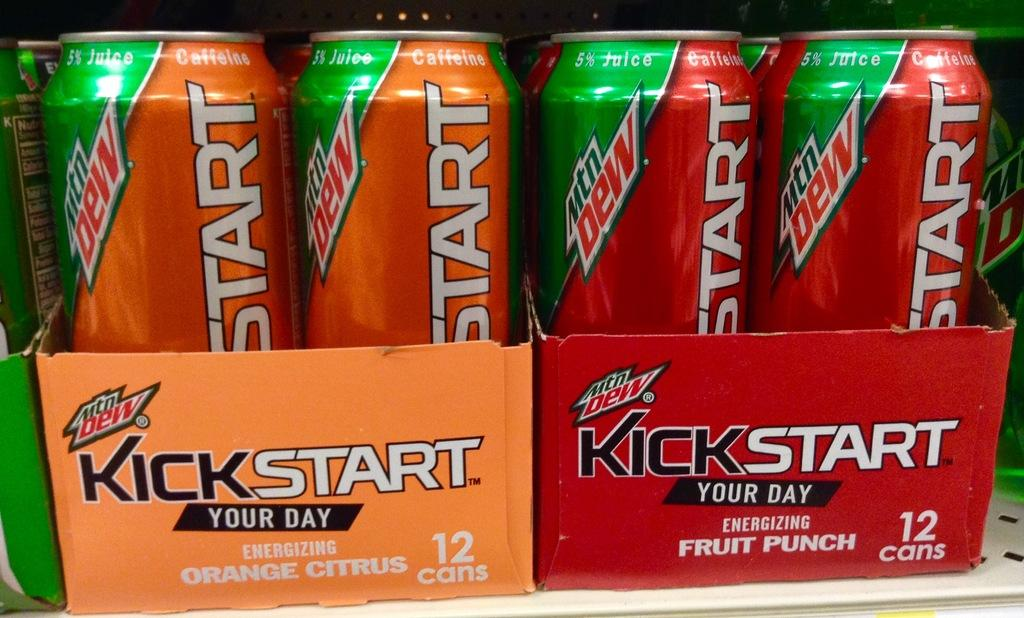What objects are present in the image? There are tins in the image. Where are the tins located? The tins are in a cardboard box. What is the cardboard box placed on? The cardboard box is on a white surface. How many deaths occurred during the week depicted in the image? There is no depiction of a week or any deaths in the image; it only shows tins in a cardboard box on a white surface. 